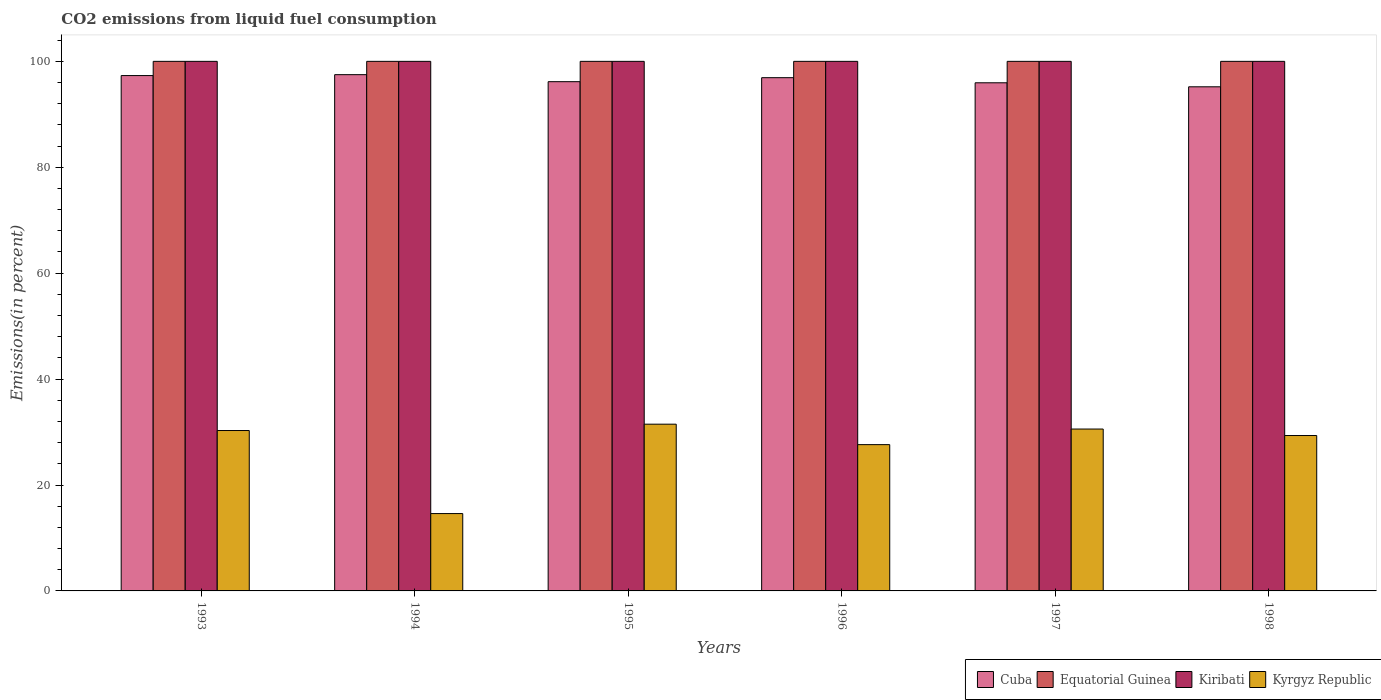How many groups of bars are there?
Offer a very short reply. 6. How many bars are there on the 5th tick from the left?
Give a very brief answer. 4. What is the label of the 1st group of bars from the left?
Your answer should be compact. 1993. In how many cases, is the number of bars for a given year not equal to the number of legend labels?
Your answer should be very brief. 0. What is the total CO2 emitted in Kiribati in 1998?
Keep it short and to the point. 100. Across all years, what is the minimum total CO2 emitted in Kyrgyz Republic?
Make the answer very short. 14.61. What is the total total CO2 emitted in Cuba in the graph?
Offer a very short reply. 579.03. What is the difference between the total CO2 emitted in Kiribati in 1993 and the total CO2 emitted in Equatorial Guinea in 1998?
Give a very brief answer. 0. What is the average total CO2 emitted in Equatorial Guinea per year?
Provide a short and direct response. 100. In the year 1998, what is the difference between the total CO2 emitted in Kyrgyz Republic and total CO2 emitted in Kiribati?
Offer a very short reply. -70.65. What is the ratio of the total CO2 emitted in Kyrgyz Republic in 1996 to that in 1998?
Ensure brevity in your answer.  0.94. What is the difference between the highest and the second highest total CO2 emitted in Kiribati?
Keep it short and to the point. 0. What is the difference between the highest and the lowest total CO2 emitted in Cuba?
Offer a terse response. 2.29. What does the 3rd bar from the left in 1994 represents?
Your response must be concise. Kiribati. What does the 4th bar from the right in 1996 represents?
Provide a succinct answer. Cuba. How many years are there in the graph?
Your answer should be very brief. 6. What is the difference between two consecutive major ticks on the Y-axis?
Ensure brevity in your answer.  20. Does the graph contain any zero values?
Offer a very short reply. No. Where does the legend appear in the graph?
Provide a succinct answer. Bottom right. How are the legend labels stacked?
Your answer should be very brief. Horizontal. What is the title of the graph?
Offer a terse response. CO2 emissions from liquid fuel consumption. Does "Australia" appear as one of the legend labels in the graph?
Provide a short and direct response. No. What is the label or title of the X-axis?
Your answer should be very brief. Years. What is the label or title of the Y-axis?
Offer a terse response. Emissions(in percent). What is the Emissions(in percent) in Cuba in 1993?
Provide a succinct answer. 97.32. What is the Emissions(in percent) of Equatorial Guinea in 1993?
Provide a short and direct response. 100. What is the Emissions(in percent) of Kyrgyz Republic in 1993?
Provide a succinct answer. 30.29. What is the Emissions(in percent) of Cuba in 1994?
Your answer should be very brief. 97.49. What is the Emissions(in percent) in Equatorial Guinea in 1994?
Provide a short and direct response. 100. What is the Emissions(in percent) in Kyrgyz Republic in 1994?
Ensure brevity in your answer.  14.61. What is the Emissions(in percent) of Cuba in 1995?
Your response must be concise. 96.16. What is the Emissions(in percent) in Kiribati in 1995?
Offer a very short reply. 100. What is the Emissions(in percent) in Kyrgyz Republic in 1995?
Make the answer very short. 31.49. What is the Emissions(in percent) in Cuba in 1996?
Your answer should be very brief. 96.92. What is the Emissions(in percent) in Kyrgyz Republic in 1996?
Your response must be concise. 27.62. What is the Emissions(in percent) in Cuba in 1997?
Keep it short and to the point. 95.95. What is the Emissions(in percent) in Kyrgyz Republic in 1997?
Make the answer very short. 30.57. What is the Emissions(in percent) of Cuba in 1998?
Offer a terse response. 95.2. What is the Emissions(in percent) in Equatorial Guinea in 1998?
Ensure brevity in your answer.  100. What is the Emissions(in percent) of Kyrgyz Republic in 1998?
Your response must be concise. 29.35. Across all years, what is the maximum Emissions(in percent) of Cuba?
Offer a very short reply. 97.49. Across all years, what is the maximum Emissions(in percent) in Equatorial Guinea?
Keep it short and to the point. 100. Across all years, what is the maximum Emissions(in percent) of Kyrgyz Republic?
Offer a terse response. 31.49. Across all years, what is the minimum Emissions(in percent) of Cuba?
Give a very brief answer. 95.2. Across all years, what is the minimum Emissions(in percent) in Equatorial Guinea?
Your answer should be compact. 100. Across all years, what is the minimum Emissions(in percent) of Kiribati?
Your response must be concise. 100. Across all years, what is the minimum Emissions(in percent) in Kyrgyz Republic?
Your answer should be compact. 14.61. What is the total Emissions(in percent) in Cuba in the graph?
Your answer should be compact. 579.03. What is the total Emissions(in percent) of Equatorial Guinea in the graph?
Provide a short and direct response. 600. What is the total Emissions(in percent) in Kiribati in the graph?
Ensure brevity in your answer.  600. What is the total Emissions(in percent) in Kyrgyz Republic in the graph?
Your answer should be compact. 163.92. What is the difference between the Emissions(in percent) of Cuba in 1993 and that in 1994?
Ensure brevity in your answer.  -0.17. What is the difference between the Emissions(in percent) of Kyrgyz Republic in 1993 and that in 1994?
Give a very brief answer. 15.68. What is the difference between the Emissions(in percent) of Cuba in 1993 and that in 1995?
Provide a succinct answer. 1.15. What is the difference between the Emissions(in percent) of Equatorial Guinea in 1993 and that in 1995?
Offer a very short reply. 0. What is the difference between the Emissions(in percent) in Kyrgyz Republic in 1993 and that in 1995?
Provide a succinct answer. -1.2. What is the difference between the Emissions(in percent) of Cuba in 1993 and that in 1996?
Make the answer very short. 0.4. What is the difference between the Emissions(in percent) in Equatorial Guinea in 1993 and that in 1996?
Your answer should be compact. 0. What is the difference between the Emissions(in percent) in Kyrgyz Republic in 1993 and that in 1996?
Your answer should be very brief. 2.66. What is the difference between the Emissions(in percent) in Cuba in 1993 and that in 1997?
Provide a short and direct response. 1.36. What is the difference between the Emissions(in percent) in Kyrgyz Republic in 1993 and that in 1997?
Your answer should be compact. -0.28. What is the difference between the Emissions(in percent) of Cuba in 1993 and that in 1998?
Your response must be concise. 2.12. What is the difference between the Emissions(in percent) of Equatorial Guinea in 1993 and that in 1998?
Ensure brevity in your answer.  0. What is the difference between the Emissions(in percent) of Kyrgyz Republic in 1993 and that in 1998?
Your response must be concise. 0.94. What is the difference between the Emissions(in percent) in Cuba in 1994 and that in 1995?
Offer a terse response. 1.32. What is the difference between the Emissions(in percent) in Kyrgyz Republic in 1994 and that in 1995?
Your answer should be very brief. -16.88. What is the difference between the Emissions(in percent) in Cuba in 1994 and that in 1996?
Offer a terse response. 0.57. What is the difference between the Emissions(in percent) of Equatorial Guinea in 1994 and that in 1996?
Provide a short and direct response. 0. What is the difference between the Emissions(in percent) in Kyrgyz Republic in 1994 and that in 1996?
Give a very brief answer. -13.02. What is the difference between the Emissions(in percent) of Cuba in 1994 and that in 1997?
Offer a terse response. 1.53. What is the difference between the Emissions(in percent) of Equatorial Guinea in 1994 and that in 1997?
Ensure brevity in your answer.  0. What is the difference between the Emissions(in percent) of Kyrgyz Republic in 1994 and that in 1997?
Provide a succinct answer. -15.96. What is the difference between the Emissions(in percent) in Cuba in 1994 and that in 1998?
Your response must be concise. 2.29. What is the difference between the Emissions(in percent) in Equatorial Guinea in 1994 and that in 1998?
Offer a terse response. 0. What is the difference between the Emissions(in percent) in Kyrgyz Republic in 1994 and that in 1998?
Give a very brief answer. -14.74. What is the difference between the Emissions(in percent) in Cuba in 1995 and that in 1996?
Offer a terse response. -0.75. What is the difference between the Emissions(in percent) of Kyrgyz Republic in 1995 and that in 1996?
Offer a terse response. 3.86. What is the difference between the Emissions(in percent) of Cuba in 1995 and that in 1997?
Offer a very short reply. 0.21. What is the difference between the Emissions(in percent) of Equatorial Guinea in 1995 and that in 1997?
Provide a short and direct response. 0. What is the difference between the Emissions(in percent) in Kyrgyz Republic in 1995 and that in 1997?
Ensure brevity in your answer.  0.92. What is the difference between the Emissions(in percent) of Cuba in 1995 and that in 1998?
Ensure brevity in your answer.  0.97. What is the difference between the Emissions(in percent) of Kiribati in 1995 and that in 1998?
Give a very brief answer. 0. What is the difference between the Emissions(in percent) in Kyrgyz Republic in 1995 and that in 1998?
Give a very brief answer. 2.14. What is the difference between the Emissions(in percent) of Cuba in 1996 and that in 1997?
Give a very brief answer. 0.96. What is the difference between the Emissions(in percent) of Equatorial Guinea in 1996 and that in 1997?
Offer a very short reply. 0. What is the difference between the Emissions(in percent) of Kyrgyz Republic in 1996 and that in 1997?
Provide a succinct answer. -2.94. What is the difference between the Emissions(in percent) in Cuba in 1996 and that in 1998?
Keep it short and to the point. 1.72. What is the difference between the Emissions(in percent) in Kiribati in 1996 and that in 1998?
Provide a short and direct response. 0. What is the difference between the Emissions(in percent) of Kyrgyz Republic in 1996 and that in 1998?
Your answer should be very brief. -1.72. What is the difference between the Emissions(in percent) of Cuba in 1997 and that in 1998?
Offer a very short reply. 0.76. What is the difference between the Emissions(in percent) of Equatorial Guinea in 1997 and that in 1998?
Provide a succinct answer. 0. What is the difference between the Emissions(in percent) in Kyrgyz Republic in 1997 and that in 1998?
Keep it short and to the point. 1.22. What is the difference between the Emissions(in percent) in Cuba in 1993 and the Emissions(in percent) in Equatorial Guinea in 1994?
Provide a succinct answer. -2.68. What is the difference between the Emissions(in percent) of Cuba in 1993 and the Emissions(in percent) of Kiribati in 1994?
Your answer should be compact. -2.68. What is the difference between the Emissions(in percent) in Cuba in 1993 and the Emissions(in percent) in Kyrgyz Republic in 1994?
Offer a terse response. 82.71. What is the difference between the Emissions(in percent) of Equatorial Guinea in 1993 and the Emissions(in percent) of Kiribati in 1994?
Make the answer very short. 0. What is the difference between the Emissions(in percent) of Equatorial Guinea in 1993 and the Emissions(in percent) of Kyrgyz Republic in 1994?
Offer a terse response. 85.39. What is the difference between the Emissions(in percent) of Kiribati in 1993 and the Emissions(in percent) of Kyrgyz Republic in 1994?
Your answer should be very brief. 85.39. What is the difference between the Emissions(in percent) of Cuba in 1993 and the Emissions(in percent) of Equatorial Guinea in 1995?
Give a very brief answer. -2.68. What is the difference between the Emissions(in percent) in Cuba in 1993 and the Emissions(in percent) in Kiribati in 1995?
Your response must be concise. -2.68. What is the difference between the Emissions(in percent) of Cuba in 1993 and the Emissions(in percent) of Kyrgyz Republic in 1995?
Keep it short and to the point. 65.83. What is the difference between the Emissions(in percent) in Equatorial Guinea in 1993 and the Emissions(in percent) in Kiribati in 1995?
Ensure brevity in your answer.  0. What is the difference between the Emissions(in percent) in Equatorial Guinea in 1993 and the Emissions(in percent) in Kyrgyz Republic in 1995?
Your answer should be compact. 68.51. What is the difference between the Emissions(in percent) in Kiribati in 1993 and the Emissions(in percent) in Kyrgyz Republic in 1995?
Provide a short and direct response. 68.51. What is the difference between the Emissions(in percent) of Cuba in 1993 and the Emissions(in percent) of Equatorial Guinea in 1996?
Offer a terse response. -2.68. What is the difference between the Emissions(in percent) of Cuba in 1993 and the Emissions(in percent) of Kiribati in 1996?
Offer a terse response. -2.68. What is the difference between the Emissions(in percent) in Cuba in 1993 and the Emissions(in percent) in Kyrgyz Republic in 1996?
Provide a succinct answer. 69.69. What is the difference between the Emissions(in percent) in Equatorial Guinea in 1993 and the Emissions(in percent) in Kyrgyz Republic in 1996?
Keep it short and to the point. 72.38. What is the difference between the Emissions(in percent) in Kiribati in 1993 and the Emissions(in percent) in Kyrgyz Republic in 1996?
Your response must be concise. 72.38. What is the difference between the Emissions(in percent) of Cuba in 1993 and the Emissions(in percent) of Equatorial Guinea in 1997?
Provide a succinct answer. -2.68. What is the difference between the Emissions(in percent) in Cuba in 1993 and the Emissions(in percent) in Kiribati in 1997?
Ensure brevity in your answer.  -2.68. What is the difference between the Emissions(in percent) of Cuba in 1993 and the Emissions(in percent) of Kyrgyz Republic in 1997?
Offer a terse response. 66.75. What is the difference between the Emissions(in percent) of Equatorial Guinea in 1993 and the Emissions(in percent) of Kiribati in 1997?
Offer a very short reply. 0. What is the difference between the Emissions(in percent) in Equatorial Guinea in 1993 and the Emissions(in percent) in Kyrgyz Republic in 1997?
Make the answer very short. 69.43. What is the difference between the Emissions(in percent) in Kiribati in 1993 and the Emissions(in percent) in Kyrgyz Republic in 1997?
Provide a short and direct response. 69.43. What is the difference between the Emissions(in percent) of Cuba in 1993 and the Emissions(in percent) of Equatorial Guinea in 1998?
Offer a very short reply. -2.68. What is the difference between the Emissions(in percent) of Cuba in 1993 and the Emissions(in percent) of Kiribati in 1998?
Provide a short and direct response. -2.68. What is the difference between the Emissions(in percent) in Cuba in 1993 and the Emissions(in percent) in Kyrgyz Republic in 1998?
Give a very brief answer. 67.97. What is the difference between the Emissions(in percent) in Equatorial Guinea in 1993 and the Emissions(in percent) in Kyrgyz Republic in 1998?
Your response must be concise. 70.65. What is the difference between the Emissions(in percent) of Kiribati in 1993 and the Emissions(in percent) of Kyrgyz Republic in 1998?
Your response must be concise. 70.65. What is the difference between the Emissions(in percent) in Cuba in 1994 and the Emissions(in percent) in Equatorial Guinea in 1995?
Ensure brevity in your answer.  -2.51. What is the difference between the Emissions(in percent) in Cuba in 1994 and the Emissions(in percent) in Kiribati in 1995?
Make the answer very short. -2.51. What is the difference between the Emissions(in percent) in Cuba in 1994 and the Emissions(in percent) in Kyrgyz Republic in 1995?
Your answer should be compact. 66. What is the difference between the Emissions(in percent) of Equatorial Guinea in 1994 and the Emissions(in percent) of Kiribati in 1995?
Give a very brief answer. 0. What is the difference between the Emissions(in percent) in Equatorial Guinea in 1994 and the Emissions(in percent) in Kyrgyz Republic in 1995?
Keep it short and to the point. 68.51. What is the difference between the Emissions(in percent) of Kiribati in 1994 and the Emissions(in percent) of Kyrgyz Republic in 1995?
Make the answer very short. 68.51. What is the difference between the Emissions(in percent) in Cuba in 1994 and the Emissions(in percent) in Equatorial Guinea in 1996?
Give a very brief answer. -2.51. What is the difference between the Emissions(in percent) in Cuba in 1994 and the Emissions(in percent) in Kiribati in 1996?
Your answer should be compact. -2.51. What is the difference between the Emissions(in percent) of Cuba in 1994 and the Emissions(in percent) of Kyrgyz Republic in 1996?
Provide a short and direct response. 69.86. What is the difference between the Emissions(in percent) in Equatorial Guinea in 1994 and the Emissions(in percent) in Kyrgyz Republic in 1996?
Your answer should be compact. 72.38. What is the difference between the Emissions(in percent) of Kiribati in 1994 and the Emissions(in percent) of Kyrgyz Republic in 1996?
Your answer should be very brief. 72.38. What is the difference between the Emissions(in percent) of Cuba in 1994 and the Emissions(in percent) of Equatorial Guinea in 1997?
Offer a very short reply. -2.51. What is the difference between the Emissions(in percent) of Cuba in 1994 and the Emissions(in percent) of Kiribati in 1997?
Offer a very short reply. -2.51. What is the difference between the Emissions(in percent) of Cuba in 1994 and the Emissions(in percent) of Kyrgyz Republic in 1997?
Your answer should be very brief. 66.92. What is the difference between the Emissions(in percent) of Equatorial Guinea in 1994 and the Emissions(in percent) of Kyrgyz Republic in 1997?
Provide a succinct answer. 69.43. What is the difference between the Emissions(in percent) in Kiribati in 1994 and the Emissions(in percent) in Kyrgyz Republic in 1997?
Provide a short and direct response. 69.43. What is the difference between the Emissions(in percent) in Cuba in 1994 and the Emissions(in percent) in Equatorial Guinea in 1998?
Your answer should be compact. -2.51. What is the difference between the Emissions(in percent) in Cuba in 1994 and the Emissions(in percent) in Kiribati in 1998?
Your answer should be compact. -2.51. What is the difference between the Emissions(in percent) of Cuba in 1994 and the Emissions(in percent) of Kyrgyz Republic in 1998?
Your answer should be very brief. 68.14. What is the difference between the Emissions(in percent) of Equatorial Guinea in 1994 and the Emissions(in percent) of Kyrgyz Republic in 1998?
Your answer should be compact. 70.65. What is the difference between the Emissions(in percent) of Kiribati in 1994 and the Emissions(in percent) of Kyrgyz Republic in 1998?
Give a very brief answer. 70.65. What is the difference between the Emissions(in percent) in Cuba in 1995 and the Emissions(in percent) in Equatorial Guinea in 1996?
Ensure brevity in your answer.  -3.84. What is the difference between the Emissions(in percent) in Cuba in 1995 and the Emissions(in percent) in Kiribati in 1996?
Give a very brief answer. -3.84. What is the difference between the Emissions(in percent) of Cuba in 1995 and the Emissions(in percent) of Kyrgyz Republic in 1996?
Provide a succinct answer. 68.54. What is the difference between the Emissions(in percent) in Equatorial Guinea in 1995 and the Emissions(in percent) in Kiribati in 1996?
Make the answer very short. 0. What is the difference between the Emissions(in percent) in Equatorial Guinea in 1995 and the Emissions(in percent) in Kyrgyz Republic in 1996?
Give a very brief answer. 72.38. What is the difference between the Emissions(in percent) in Kiribati in 1995 and the Emissions(in percent) in Kyrgyz Republic in 1996?
Give a very brief answer. 72.38. What is the difference between the Emissions(in percent) of Cuba in 1995 and the Emissions(in percent) of Equatorial Guinea in 1997?
Make the answer very short. -3.84. What is the difference between the Emissions(in percent) of Cuba in 1995 and the Emissions(in percent) of Kiribati in 1997?
Offer a terse response. -3.84. What is the difference between the Emissions(in percent) of Cuba in 1995 and the Emissions(in percent) of Kyrgyz Republic in 1997?
Give a very brief answer. 65.59. What is the difference between the Emissions(in percent) in Equatorial Guinea in 1995 and the Emissions(in percent) in Kiribati in 1997?
Your response must be concise. 0. What is the difference between the Emissions(in percent) of Equatorial Guinea in 1995 and the Emissions(in percent) of Kyrgyz Republic in 1997?
Provide a short and direct response. 69.43. What is the difference between the Emissions(in percent) of Kiribati in 1995 and the Emissions(in percent) of Kyrgyz Republic in 1997?
Provide a short and direct response. 69.43. What is the difference between the Emissions(in percent) in Cuba in 1995 and the Emissions(in percent) in Equatorial Guinea in 1998?
Ensure brevity in your answer.  -3.84. What is the difference between the Emissions(in percent) in Cuba in 1995 and the Emissions(in percent) in Kiribati in 1998?
Your answer should be very brief. -3.84. What is the difference between the Emissions(in percent) of Cuba in 1995 and the Emissions(in percent) of Kyrgyz Republic in 1998?
Keep it short and to the point. 66.82. What is the difference between the Emissions(in percent) of Equatorial Guinea in 1995 and the Emissions(in percent) of Kyrgyz Republic in 1998?
Ensure brevity in your answer.  70.65. What is the difference between the Emissions(in percent) in Kiribati in 1995 and the Emissions(in percent) in Kyrgyz Republic in 1998?
Your response must be concise. 70.65. What is the difference between the Emissions(in percent) in Cuba in 1996 and the Emissions(in percent) in Equatorial Guinea in 1997?
Provide a succinct answer. -3.08. What is the difference between the Emissions(in percent) in Cuba in 1996 and the Emissions(in percent) in Kiribati in 1997?
Give a very brief answer. -3.08. What is the difference between the Emissions(in percent) of Cuba in 1996 and the Emissions(in percent) of Kyrgyz Republic in 1997?
Provide a short and direct response. 66.35. What is the difference between the Emissions(in percent) of Equatorial Guinea in 1996 and the Emissions(in percent) of Kyrgyz Republic in 1997?
Provide a succinct answer. 69.43. What is the difference between the Emissions(in percent) in Kiribati in 1996 and the Emissions(in percent) in Kyrgyz Republic in 1997?
Your answer should be compact. 69.43. What is the difference between the Emissions(in percent) of Cuba in 1996 and the Emissions(in percent) of Equatorial Guinea in 1998?
Offer a terse response. -3.08. What is the difference between the Emissions(in percent) of Cuba in 1996 and the Emissions(in percent) of Kiribati in 1998?
Make the answer very short. -3.08. What is the difference between the Emissions(in percent) of Cuba in 1996 and the Emissions(in percent) of Kyrgyz Republic in 1998?
Keep it short and to the point. 67.57. What is the difference between the Emissions(in percent) in Equatorial Guinea in 1996 and the Emissions(in percent) in Kyrgyz Republic in 1998?
Your answer should be very brief. 70.65. What is the difference between the Emissions(in percent) of Kiribati in 1996 and the Emissions(in percent) of Kyrgyz Republic in 1998?
Provide a succinct answer. 70.65. What is the difference between the Emissions(in percent) in Cuba in 1997 and the Emissions(in percent) in Equatorial Guinea in 1998?
Ensure brevity in your answer.  -4.05. What is the difference between the Emissions(in percent) in Cuba in 1997 and the Emissions(in percent) in Kiribati in 1998?
Offer a terse response. -4.05. What is the difference between the Emissions(in percent) of Cuba in 1997 and the Emissions(in percent) of Kyrgyz Republic in 1998?
Make the answer very short. 66.61. What is the difference between the Emissions(in percent) of Equatorial Guinea in 1997 and the Emissions(in percent) of Kiribati in 1998?
Offer a very short reply. 0. What is the difference between the Emissions(in percent) of Equatorial Guinea in 1997 and the Emissions(in percent) of Kyrgyz Republic in 1998?
Provide a short and direct response. 70.65. What is the difference between the Emissions(in percent) in Kiribati in 1997 and the Emissions(in percent) in Kyrgyz Republic in 1998?
Offer a terse response. 70.65. What is the average Emissions(in percent) of Cuba per year?
Your answer should be very brief. 96.51. What is the average Emissions(in percent) of Kyrgyz Republic per year?
Make the answer very short. 27.32. In the year 1993, what is the difference between the Emissions(in percent) of Cuba and Emissions(in percent) of Equatorial Guinea?
Provide a succinct answer. -2.68. In the year 1993, what is the difference between the Emissions(in percent) of Cuba and Emissions(in percent) of Kiribati?
Make the answer very short. -2.68. In the year 1993, what is the difference between the Emissions(in percent) in Cuba and Emissions(in percent) in Kyrgyz Republic?
Keep it short and to the point. 67.03. In the year 1993, what is the difference between the Emissions(in percent) of Equatorial Guinea and Emissions(in percent) of Kyrgyz Republic?
Provide a short and direct response. 69.71. In the year 1993, what is the difference between the Emissions(in percent) in Kiribati and Emissions(in percent) in Kyrgyz Republic?
Offer a terse response. 69.71. In the year 1994, what is the difference between the Emissions(in percent) in Cuba and Emissions(in percent) in Equatorial Guinea?
Your response must be concise. -2.51. In the year 1994, what is the difference between the Emissions(in percent) of Cuba and Emissions(in percent) of Kiribati?
Provide a short and direct response. -2.51. In the year 1994, what is the difference between the Emissions(in percent) of Cuba and Emissions(in percent) of Kyrgyz Republic?
Keep it short and to the point. 82.88. In the year 1994, what is the difference between the Emissions(in percent) of Equatorial Guinea and Emissions(in percent) of Kyrgyz Republic?
Ensure brevity in your answer.  85.39. In the year 1994, what is the difference between the Emissions(in percent) in Kiribati and Emissions(in percent) in Kyrgyz Republic?
Ensure brevity in your answer.  85.39. In the year 1995, what is the difference between the Emissions(in percent) in Cuba and Emissions(in percent) in Equatorial Guinea?
Provide a short and direct response. -3.84. In the year 1995, what is the difference between the Emissions(in percent) in Cuba and Emissions(in percent) in Kiribati?
Ensure brevity in your answer.  -3.84. In the year 1995, what is the difference between the Emissions(in percent) of Cuba and Emissions(in percent) of Kyrgyz Republic?
Make the answer very short. 64.68. In the year 1995, what is the difference between the Emissions(in percent) of Equatorial Guinea and Emissions(in percent) of Kiribati?
Your response must be concise. 0. In the year 1995, what is the difference between the Emissions(in percent) in Equatorial Guinea and Emissions(in percent) in Kyrgyz Republic?
Provide a succinct answer. 68.51. In the year 1995, what is the difference between the Emissions(in percent) of Kiribati and Emissions(in percent) of Kyrgyz Republic?
Offer a terse response. 68.51. In the year 1996, what is the difference between the Emissions(in percent) in Cuba and Emissions(in percent) in Equatorial Guinea?
Keep it short and to the point. -3.08. In the year 1996, what is the difference between the Emissions(in percent) of Cuba and Emissions(in percent) of Kiribati?
Keep it short and to the point. -3.08. In the year 1996, what is the difference between the Emissions(in percent) in Cuba and Emissions(in percent) in Kyrgyz Republic?
Offer a very short reply. 69.29. In the year 1996, what is the difference between the Emissions(in percent) of Equatorial Guinea and Emissions(in percent) of Kyrgyz Republic?
Give a very brief answer. 72.38. In the year 1996, what is the difference between the Emissions(in percent) of Kiribati and Emissions(in percent) of Kyrgyz Republic?
Your answer should be very brief. 72.38. In the year 1997, what is the difference between the Emissions(in percent) of Cuba and Emissions(in percent) of Equatorial Guinea?
Provide a short and direct response. -4.05. In the year 1997, what is the difference between the Emissions(in percent) of Cuba and Emissions(in percent) of Kiribati?
Give a very brief answer. -4.05. In the year 1997, what is the difference between the Emissions(in percent) in Cuba and Emissions(in percent) in Kyrgyz Republic?
Give a very brief answer. 65.39. In the year 1997, what is the difference between the Emissions(in percent) in Equatorial Guinea and Emissions(in percent) in Kiribati?
Your response must be concise. 0. In the year 1997, what is the difference between the Emissions(in percent) in Equatorial Guinea and Emissions(in percent) in Kyrgyz Republic?
Your answer should be very brief. 69.43. In the year 1997, what is the difference between the Emissions(in percent) in Kiribati and Emissions(in percent) in Kyrgyz Republic?
Your answer should be compact. 69.43. In the year 1998, what is the difference between the Emissions(in percent) in Cuba and Emissions(in percent) in Equatorial Guinea?
Give a very brief answer. -4.8. In the year 1998, what is the difference between the Emissions(in percent) of Cuba and Emissions(in percent) of Kiribati?
Your response must be concise. -4.8. In the year 1998, what is the difference between the Emissions(in percent) of Cuba and Emissions(in percent) of Kyrgyz Republic?
Provide a succinct answer. 65.85. In the year 1998, what is the difference between the Emissions(in percent) of Equatorial Guinea and Emissions(in percent) of Kyrgyz Republic?
Provide a short and direct response. 70.65. In the year 1998, what is the difference between the Emissions(in percent) in Kiribati and Emissions(in percent) in Kyrgyz Republic?
Provide a short and direct response. 70.65. What is the ratio of the Emissions(in percent) of Cuba in 1993 to that in 1994?
Your response must be concise. 1. What is the ratio of the Emissions(in percent) in Equatorial Guinea in 1993 to that in 1994?
Keep it short and to the point. 1. What is the ratio of the Emissions(in percent) of Kyrgyz Republic in 1993 to that in 1994?
Offer a terse response. 2.07. What is the ratio of the Emissions(in percent) of Cuba in 1993 to that in 1995?
Keep it short and to the point. 1.01. What is the ratio of the Emissions(in percent) in Kiribati in 1993 to that in 1995?
Ensure brevity in your answer.  1. What is the ratio of the Emissions(in percent) of Kyrgyz Republic in 1993 to that in 1995?
Give a very brief answer. 0.96. What is the ratio of the Emissions(in percent) in Equatorial Guinea in 1993 to that in 1996?
Provide a short and direct response. 1. What is the ratio of the Emissions(in percent) of Kiribati in 1993 to that in 1996?
Offer a terse response. 1. What is the ratio of the Emissions(in percent) of Kyrgyz Republic in 1993 to that in 1996?
Offer a very short reply. 1.1. What is the ratio of the Emissions(in percent) in Cuba in 1993 to that in 1997?
Keep it short and to the point. 1.01. What is the ratio of the Emissions(in percent) of Kiribati in 1993 to that in 1997?
Your response must be concise. 1. What is the ratio of the Emissions(in percent) in Cuba in 1993 to that in 1998?
Give a very brief answer. 1.02. What is the ratio of the Emissions(in percent) in Kyrgyz Republic in 1993 to that in 1998?
Your answer should be very brief. 1.03. What is the ratio of the Emissions(in percent) of Cuba in 1994 to that in 1995?
Offer a very short reply. 1.01. What is the ratio of the Emissions(in percent) in Equatorial Guinea in 1994 to that in 1995?
Keep it short and to the point. 1. What is the ratio of the Emissions(in percent) in Kiribati in 1994 to that in 1995?
Your answer should be compact. 1. What is the ratio of the Emissions(in percent) of Kyrgyz Republic in 1994 to that in 1995?
Offer a terse response. 0.46. What is the ratio of the Emissions(in percent) of Cuba in 1994 to that in 1996?
Ensure brevity in your answer.  1.01. What is the ratio of the Emissions(in percent) of Kiribati in 1994 to that in 1996?
Offer a terse response. 1. What is the ratio of the Emissions(in percent) in Kyrgyz Republic in 1994 to that in 1996?
Your response must be concise. 0.53. What is the ratio of the Emissions(in percent) of Cuba in 1994 to that in 1997?
Your response must be concise. 1.02. What is the ratio of the Emissions(in percent) of Equatorial Guinea in 1994 to that in 1997?
Your response must be concise. 1. What is the ratio of the Emissions(in percent) in Kyrgyz Republic in 1994 to that in 1997?
Offer a very short reply. 0.48. What is the ratio of the Emissions(in percent) of Cuba in 1994 to that in 1998?
Offer a very short reply. 1.02. What is the ratio of the Emissions(in percent) in Equatorial Guinea in 1994 to that in 1998?
Your answer should be very brief. 1. What is the ratio of the Emissions(in percent) of Kiribati in 1994 to that in 1998?
Make the answer very short. 1. What is the ratio of the Emissions(in percent) in Kyrgyz Republic in 1994 to that in 1998?
Your answer should be compact. 0.5. What is the ratio of the Emissions(in percent) of Kyrgyz Republic in 1995 to that in 1996?
Provide a short and direct response. 1.14. What is the ratio of the Emissions(in percent) of Cuba in 1995 to that in 1997?
Offer a very short reply. 1. What is the ratio of the Emissions(in percent) of Equatorial Guinea in 1995 to that in 1997?
Give a very brief answer. 1. What is the ratio of the Emissions(in percent) of Kiribati in 1995 to that in 1997?
Offer a very short reply. 1. What is the ratio of the Emissions(in percent) of Kyrgyz Republic in 1995 to that in 1997?
Make the answer very short. 1.03. What is the ratio of the Emissions(in percent) of Cuba in 1995 to that in 1998?
Offer a terse response. 1.01. What is the ratio of the Emissions(in percent) in Kiribati in 1995 to that in 1998?
Offer a terse response. 1. What is the ratio of the Emissions(in percent) in Kyrgyz Republic in 1995 to that in 1998?
Keep it short and to the point. 1.07. What is the ratio of the Emissions(in percent) of Equatorial Guinea in 1996 to that in 1997?
Ensure brevity in your answer.  1. What is the ratio of the Emissions(in percent) in Kiribati in 1996 to that in 1997?
Provide a short and direct response. 1. What is the ratio of the Emissions(in percent) of Kyrgyz Republic in 1996 to that in 1997?
Give a very brief answer. 0.9. What is the ratio of the Emissions(in percent) in Cuba in 1996 to that in 1998?
Ensure brevity in your answer.  1.02. What is the ratio of the Emissions(in percent) of Equatorial Guinea in 1996 to that in 1998?
Provide a short and direct response. 1. What is the ratio of the Emissions(in percent) in Kyrgyz Republic in 1996 to that in 1998?
Provide a short and direct response. 0.94. What is the ratio of the Emissions(in percent) of Cuba in 1997 to that in 1998?
Make the answer very short. 1.01. What is the ratio of the Emissions(in percent) in Kyrgyz Republic in 1997 to that in 1998?
Provide a short and direct response. 1.04. What is the difference between the highest and the second highest Emissions(in percent) of Cuba?
Your response must be concise. 0.17. What is the difference between the highest and the second highest Emissions(in percent) of Equatorial Guinea?
Keep it short and to the point. 0. What is the difference between the highest and the second highest Emissions(in percent) of Kiribati?
Your response must be concise. 0. What is the difference between the highest and the second highest Emissions(in percent) in Kyrgyz Republic?
Offer a very short reply. 0.92. What is the difference between the highest and the lowest Emissions(in percent) of Cuba?
Make the answer very short. 2.29. What is the difference between the highest and the lowest Emissions(in percent) in Kiribati?
Offer a terse response. 0. What is the difference between the highest and the lowest Emissions(in percent) in Kyrgyz Republic?
Keep it short and to the point. 16.88. 